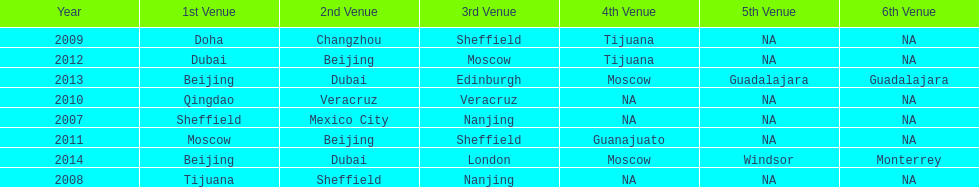What years had the most venues? 2013, 2014. 